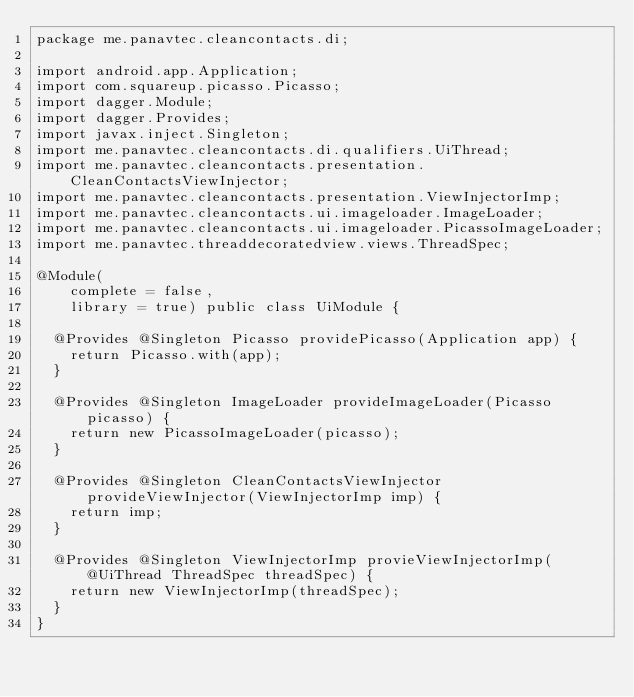Convert code to text. <code><loc_0><loc_0><loc_500><loc_500><_Java_>package me.panavtec.cleancontacts.di;

import android.app.Application;
import com.squareup.picasso.Picasso;
import dagger.Module;
import dagger.Provides;
import javax.inject.Singleton;
import me.panavtec.cleancontacts.di.qualifiers.UiThread;
import me.panavtec.cleancontacts.presentation.CleanContactsViewInjector;
import me.panavtec.cleancontacts.presentation.ViewInjectorImp;
import me.panavtec.cleancontacts.ui.imageloader.ImageLoader;
import me.panavtec.cleancontacts.ui.imageloader.PicassoImageLoader;
import me.panavtec.threaddecoratedview.views.ThreadSpec;

@Module(
    complete = false,
    library = true) public class UiModule {

  @Provides @Singleton Picasso providePicasso(Application app) {
    return Picasso.with(app);
  }

  @Provides @Singleton ImageLoader provideImageLoader(Picasso picasso) {
    return new PicassoImageLoader(picasso);
  }

  @Provides @Singleton CleanContactsViewInjector provideViewInjector(ViewInjectorImp imp) {
    return imp;
  }

  @Provides @Singleton ViewInjectorImp provieViewInjectorImp(@UiThread ThreadSpec threadSpec) {
    return new ViewInjectorImp(threadSpec);
  }
}
</code> 